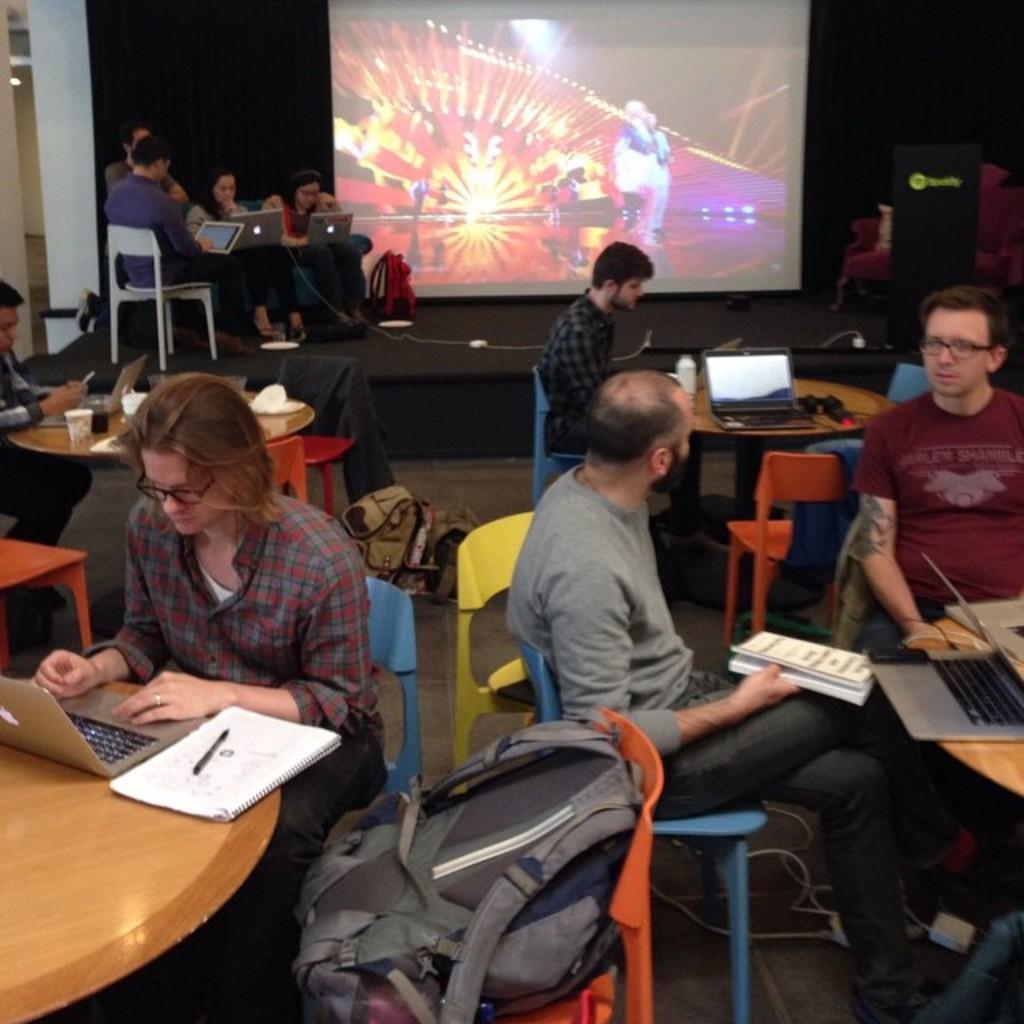Could you give a brief overview of what you see in this image? In this picture there are several people sitting on a table with their laptops and notebooks. In the background we also observe a projector screen. 